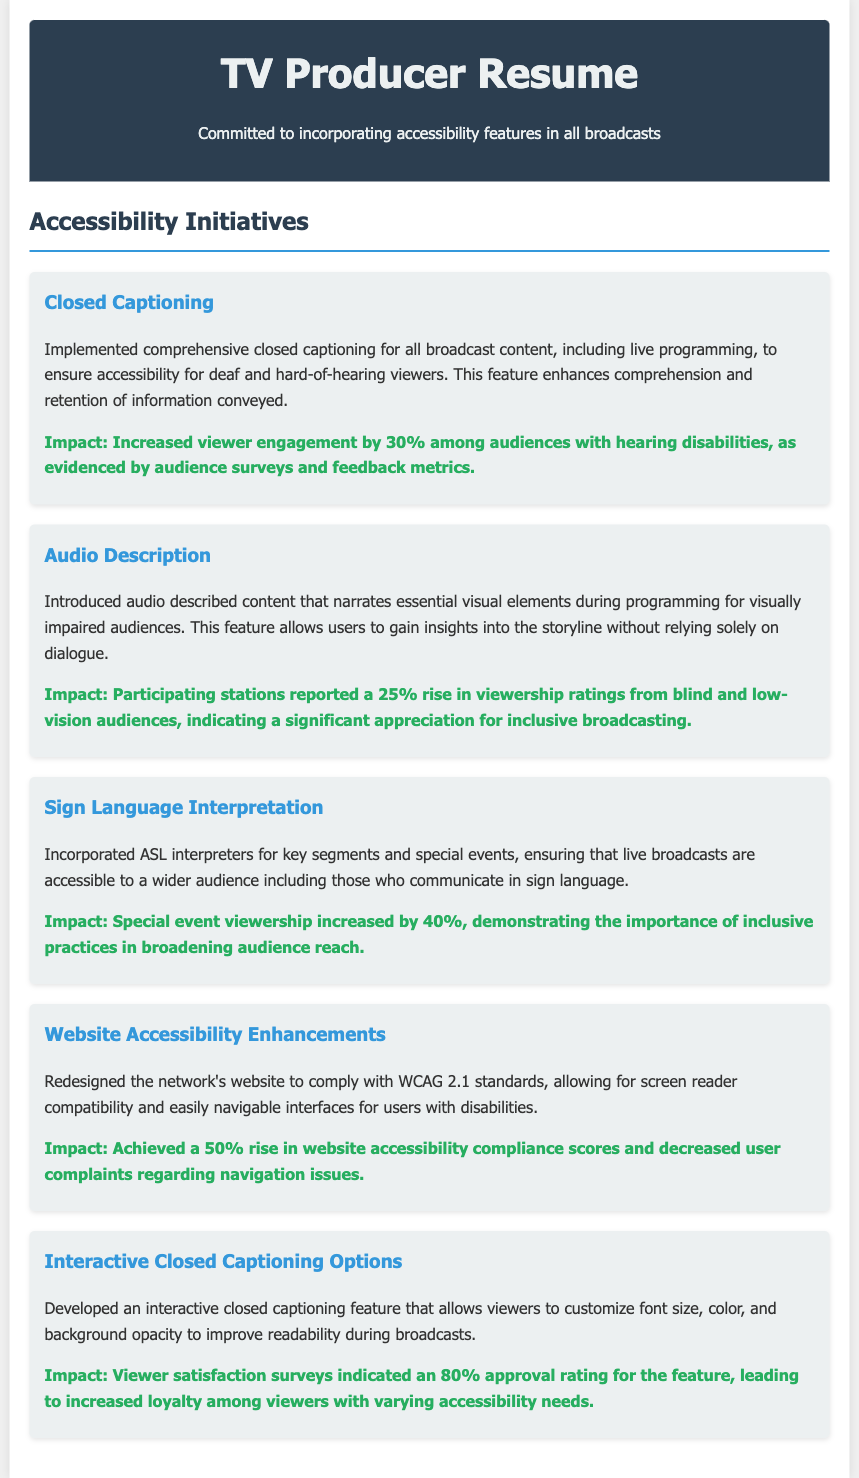What accessibility feature was implemented for deaf viewers? The document mentions that comprehensive closed captioning was implemented for all broadcast content.
Answer: Closed Captioning What percentage increase in viewership ratings was reported from blind and low-vision audiences? According to the document, a 25% rise in viewership ratings from blind and low-vision audiences was observed.
Answer: 25% What feature allows viewers to customize closed captioning? The document describes an interactive closed captioning feature that allows viewers to customize font size, color, and background opacity.
Answer: Interactive Closed Captioning Options What compliance standards were the website accessibility enhancements redesigned to meet? The website enhancements were redesigned to comply with WCAG 2.1 standards.
Answer: WCAG 2.1 By what percentage did special event viewership increase after incorporating ASL interpreters? The document indicates that special event viewership increased by 40% after incorporating ASL interpreters.
Answer: 40% What was the approval rating for the interactive closed captioning feature according to viewer satisfaction surveys? Viewer satisfaction surveys indicated an 80% approval rating for the interactive closed captioning feature.
Answer: 80% What initiative was taken to improve online navigation for users with disabilities? The network's website was redesigned to comply with accessibility standards to improve navigation for users with disabilities.
Answer: Website Accessibility Enhancements What is the overarching commitment stated in the resume? The resume states a commitment to incorporating accessibility features in all broadcasts.
Answer: Incorporating accessibility features 